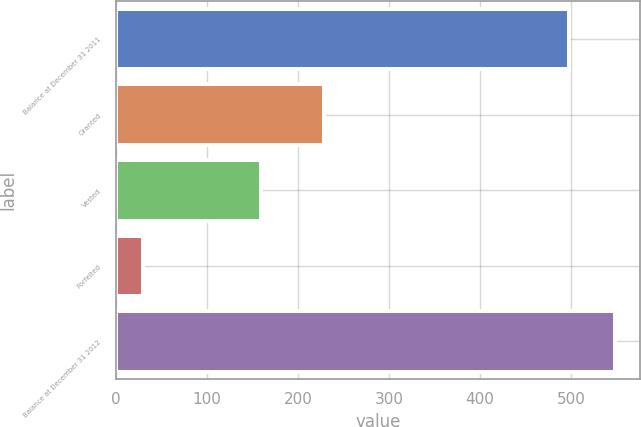Convert chart to OTSL. <chart><loc_0><loc_0><loc_500><loc_500><bar_chart><fcel>Balance at December 31 2011<fcel>Granted<fcel>Vested<fcel>Forfeited<fcel>Balance at December 31 2012<nl><fcel>497<fcel>229<fcel>159<fcel>30<fcel>547.7<nl></chart> 